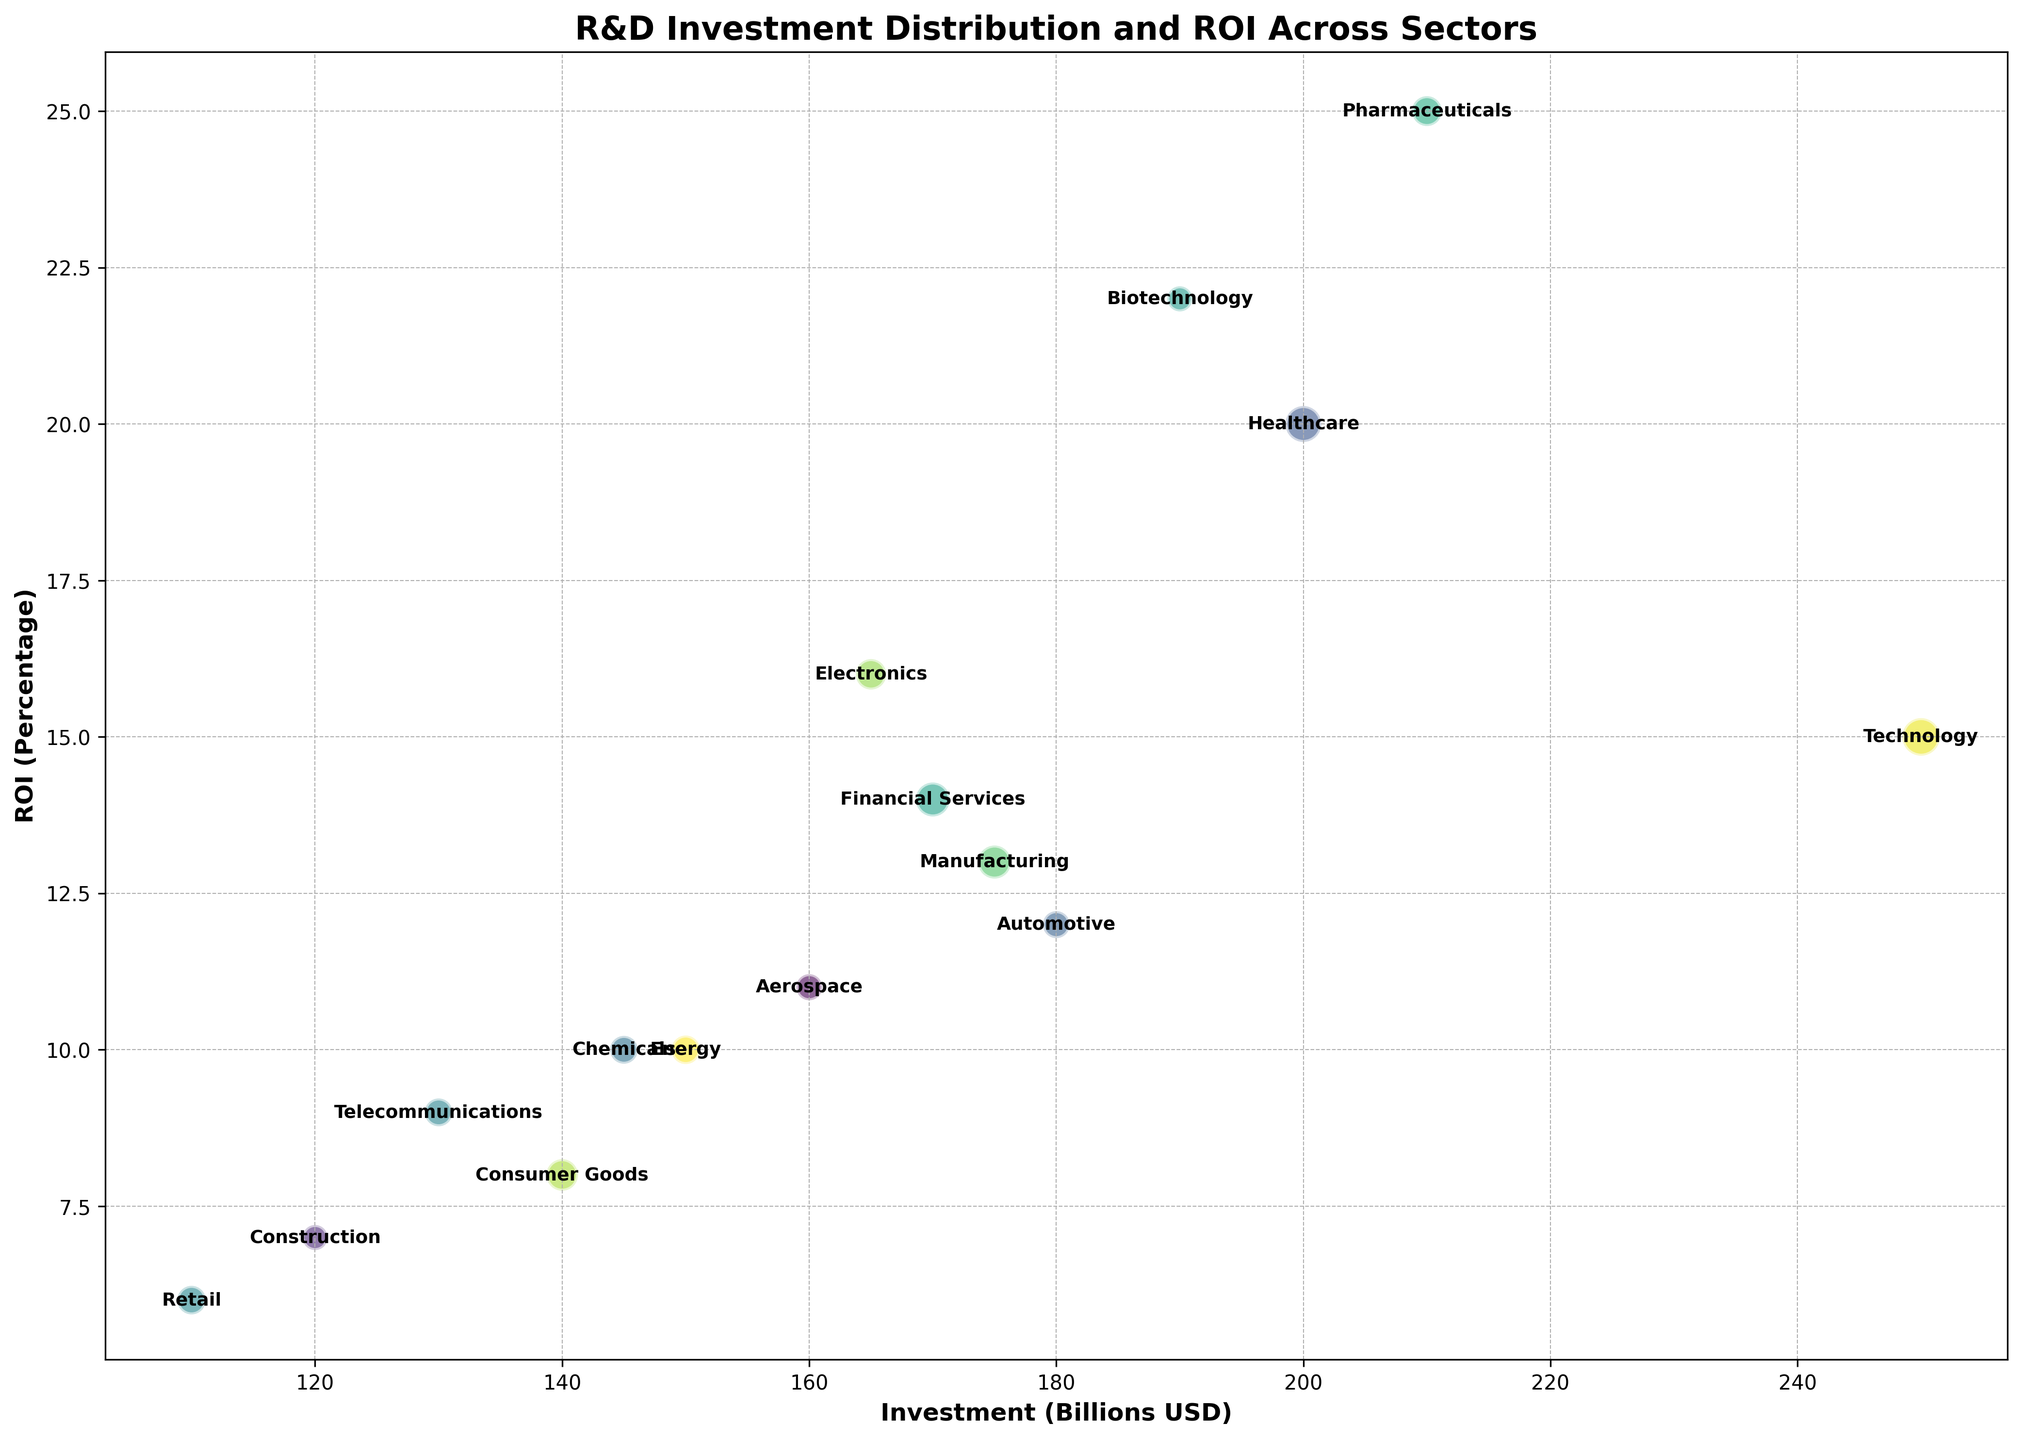Which sector has the highest ROI? The highest ROI can be found by looking for the bubble that is positioned highest along the Y-axis. The Pharmaceuticals sector shows the highest ROI at 25%.
Answer: Pharmaceuticals Which sector has the largest investment and how much is it? The sector with the largest investment is identified by locating the bubble furthest to the right on the X-axis. The Technology sector has the largest investment, which is 250 billion USD.
Answer: Technology Compare the ROI of the sector with the largest investment to the sector with the smallest investment. Identify the sectors with the largest and smallest investments, then compare their ROI percentages. The Technology sector has the largest investment with an ROI of 15%, whereas the Retail sector has the smallest investment with an ROI of 6%.
Answer: Technology: 15%, Retail: 6% How does the ROI of the Healthcare sector compare to the Biotechnology sector? Find the corresponding bubbles for Healthcare and Biotechnology sectors and compare their Y-axis positions for ROI. The Healthcare sector has an ROI of 20%, whereas Biotechnology has an ROI of 22%.
Answer: Healthcare: 20%, Biotechnology: 22% What is the average ROI of the sectors with more than 100 companies? First, identify sectors with more than 100 companies: Technology, Healthcare, Financial Services, Manufacturing, and Electronics. Then, calculate the average of their ROIs: (15% + 20% + 14% + 13% + 16%) / 5 = 15.6%
Answer: 15.6% Which sector has the smallest number of companies and what is its size? Identify the smallest bubble by availability which represents the smallest number of companies. The Biotechnology sector has the smallest number of companies, which is 60.
Answer: Biotechnology, 60 Between Energy and Chemicals, which sector has a better ROI and by how much? Compare the ROIs of the Energy sector (10%) and Chemicals sector (10%) by looking at their heights on the Y-axis. As their ROIs are equal, there is no difference between them.
Answer: Equal, 0% Which sector has a higher ROI: Aerospace or Automotive, and what are their respective ROIs? Compare the ROIs by looking at the bubble heights on the Y-axis for Aerospace and Automotive. Aerospace has an ROI of 11%, whereas Automotive has an ROI of 12%.
Answer: Automotive: 12%, Aerospace: 11% Examine the Telecommunications sector. How does its ROI compare to the median ROI of all sectors? First, calculate the median ROI for all sectors, then compare it to the Telecommunications sector’s ROI. Median ROI is the middle value in an ordered list: (6, 7, 8, 9, 10, 10, 11, 12, 13, 14, 15, 16, 20, 22, 25), which is 11%. Telecommunications ROI is 9%.
Answer: Telecommunications: 9%, Median: 11% What's the sum of investment for the sectors with an ROI greater than 15%? Identify sectors with ROI > 15%: Biotechnology, Pharmaceuticals, Healthcare, and Electronics. Sum their investments: 190 + 210 + 200 + 165 = 765 billion USD.
Answer: 765 billion USD 